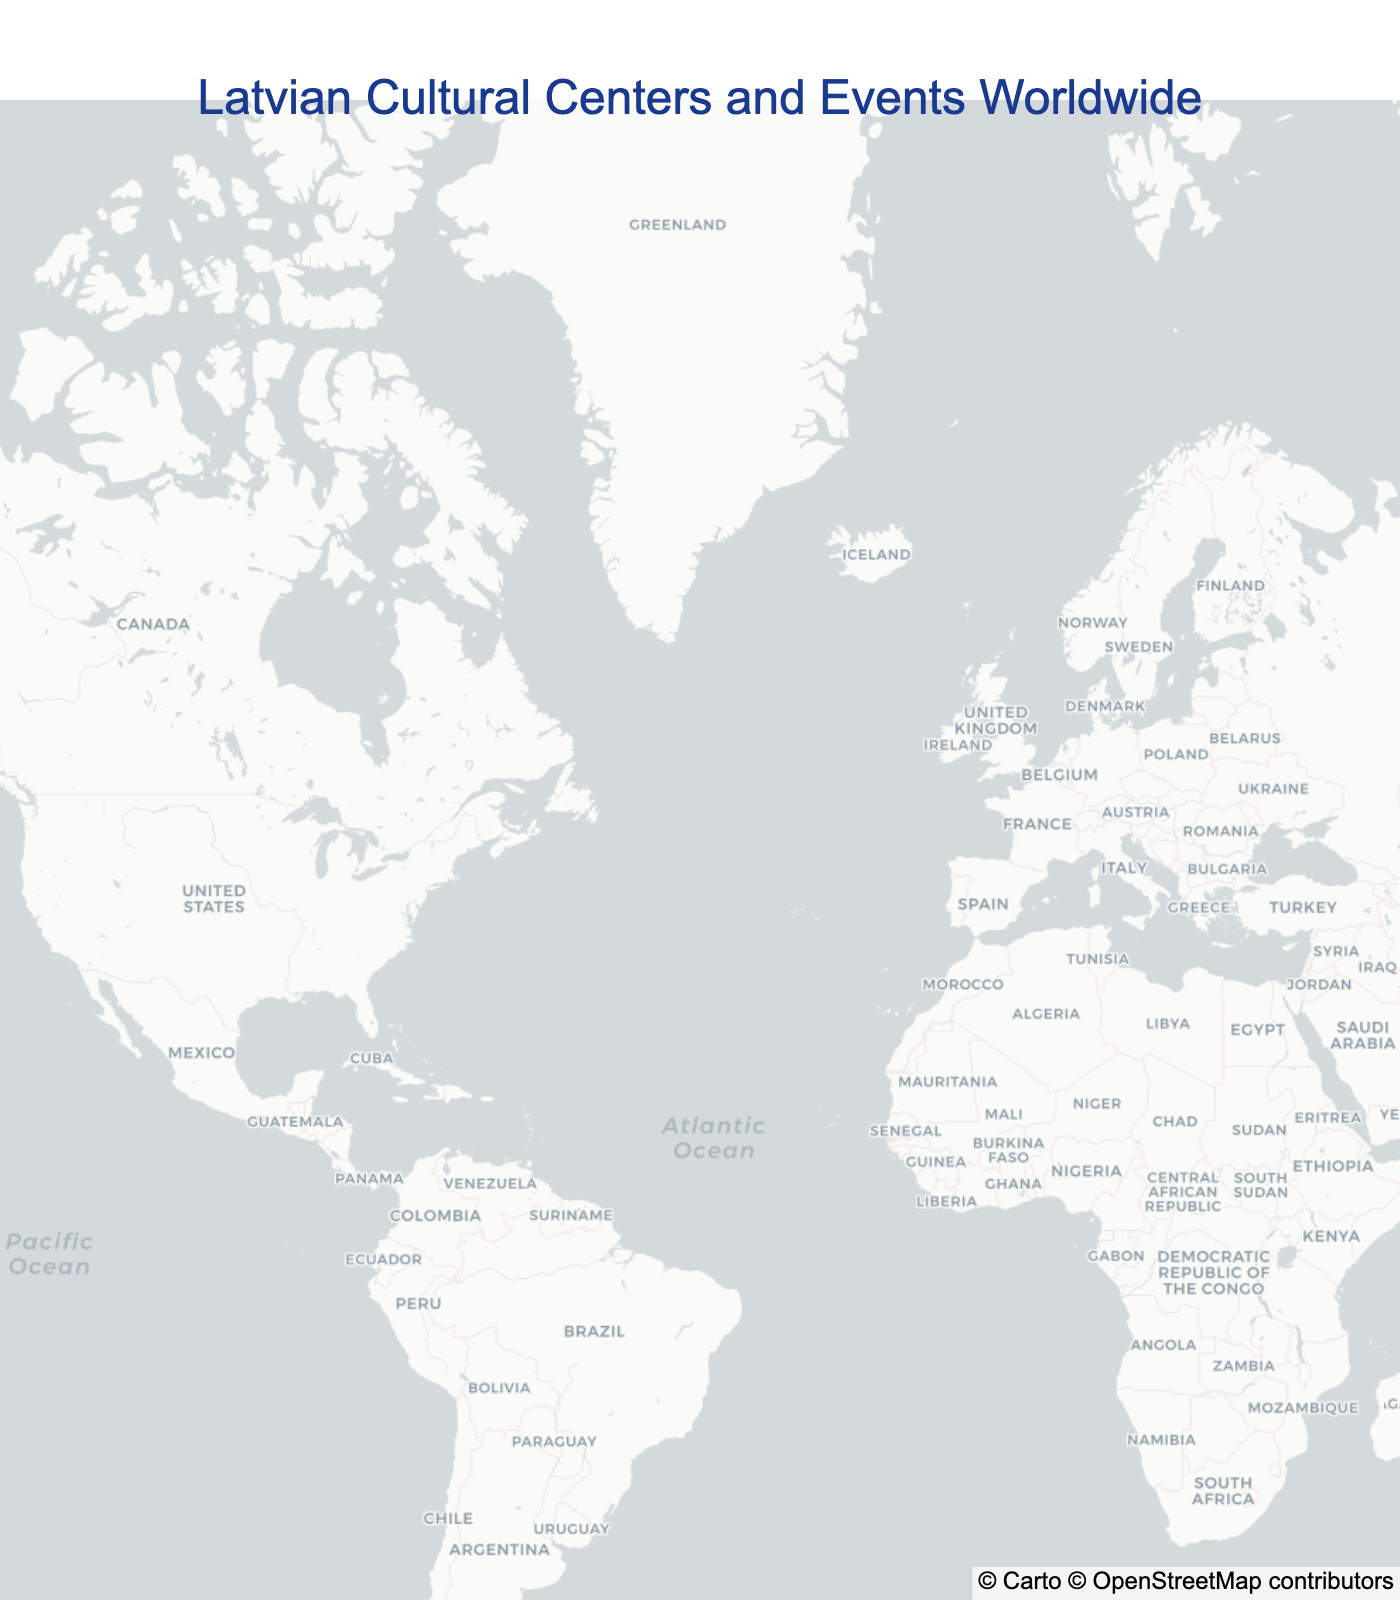What's the title of the plot? The title is typically located at the top center of the plot and is displayed in large font to give an immediate overview of the content.
Answer: Latvian Cultural Centers and Events Worldwide How many locations are marked on the map? To answer this, one needs to count the number of marked points (stars) on the map.
Answer: 10 Which event is associated with the Latvian Society of Seattle? By looking at the hover text or legend, one can identify the specific event associated with each marked location.
Answer: Annual Latvian Song Festival Which location is the furthest south? Identify the latitude coordinates on the map, and pinpoint which location has the lowest latitude value, indicating it is the furthest south.
Answer: Latvian Association in Australia How many events are located in North America? To determine the number of events in North America, count the number of markers within the geographic boundaries of North America (Canada, the USA, and Mexico).
Answer: 6 Which event occurs closest to the center of Europe? Europe’s center is roughly around central Germany. Identify the events and locations within Europe, then select the one closest to this central point.
Answer: Latvian Art Exhibition in Munster What is the longitude of the Latvian House London? The exact longitude can be found by examining the hover text or directly locating the Latvian House London on the map and checking its coordinates.
Answer: -0.1278 How many events happen in cities located on the coast? Analyze which of the marked locations are in coastal cities by recognizing their geographic positions and noting their proximity to coastlines.
Answer: 4 Which events are in cities south of 40 degrees latitude? By looking at the latitude values, identify which events are located south of the 40 degrees latitude line. This requires checking the hover data for each marker.
Answer: Latvian Center Garezers and Latvian Association in Australia What is the most central location among all these marked points? To find the most central location, calculate the average latitude and longitude of all points and identify the closest point to this mean.
Answer: Latvian Cultural Center Toronto 